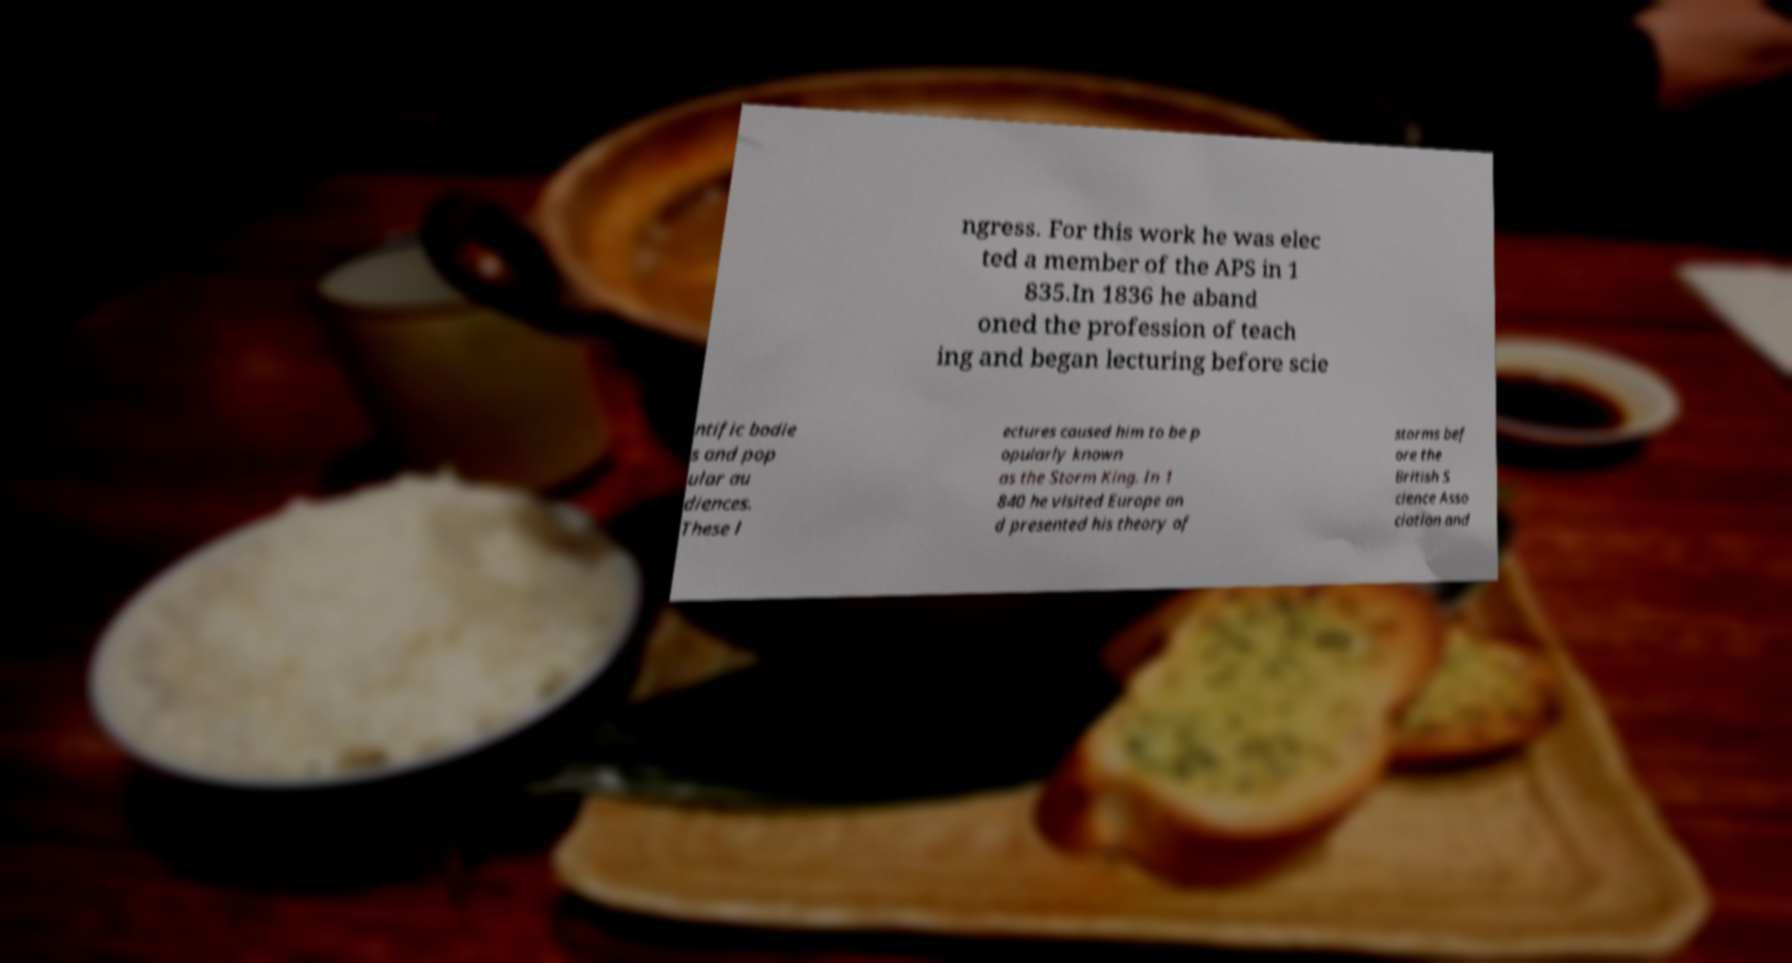Please identify and transcribe the text found in this image. ngress. For this work he was elec ted a member of the APS in 1 835.In 1836 he aband oned the profession of teach ing and began lecturing before scie ntific bodie s and pop ular au diences. These l ectures caused him to be p opularly known as the Storm King. In 1 840 he visited Europe an d presented his theory of storms bef ore the British S cience Asso ciation and 